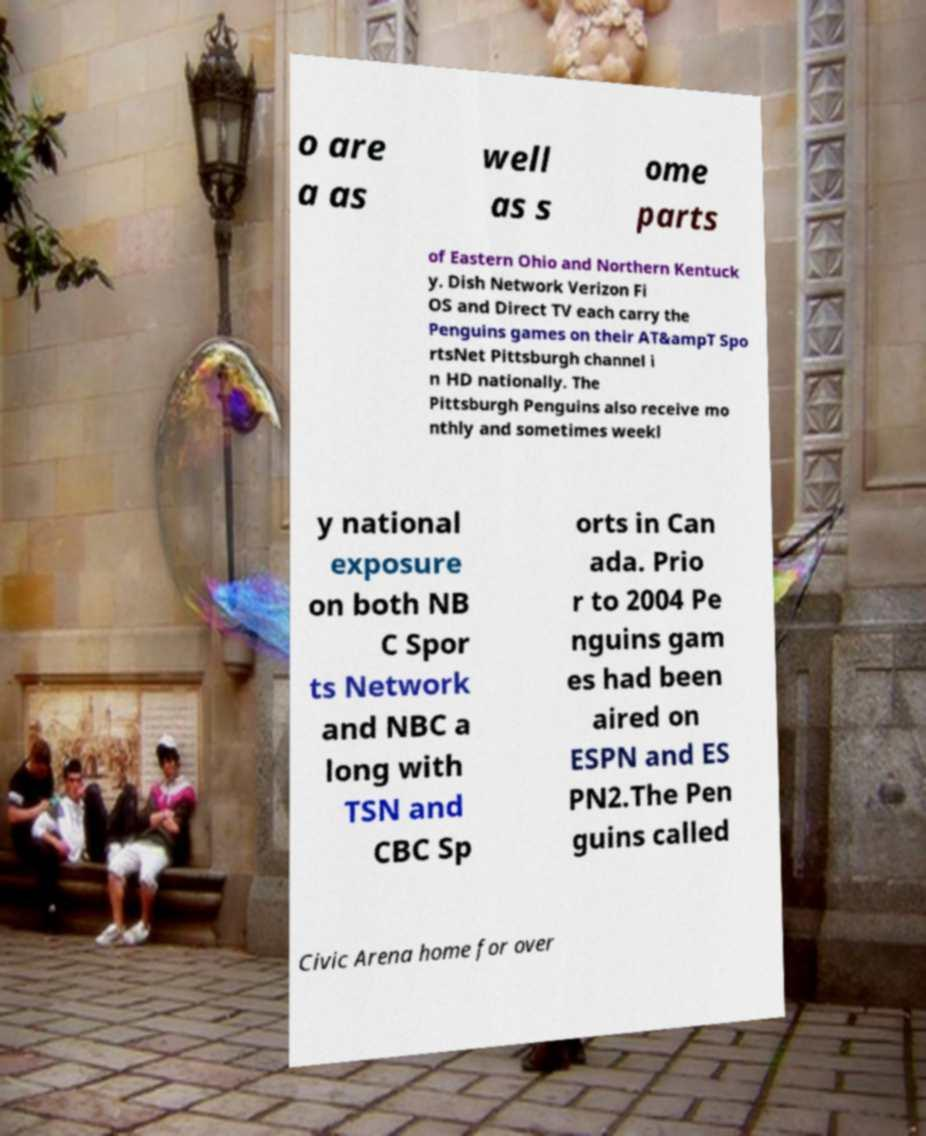Could you assist in decoding the text presented in this image and type it out clearly? o are a as well as s ome parts of Eastern Ohio and Northern Kentuck y. Dish Network Verizon Fi OS and Direct TV each carry the Penguins games on their AT&ampT Spo rtsNet Pittsburgh channel i n HD nationally. The Pittsburgh Penguins also receive mo nthly and sometimes weekl y national exposure on both NB C Spor ts Network and NBC a long with TSN and CBC Sp orts in Can ada. Prio r to 2004 Pe nguins gam es had been aired on ESPN and ES PN2.The Pen guins called Civic Arena home for over 